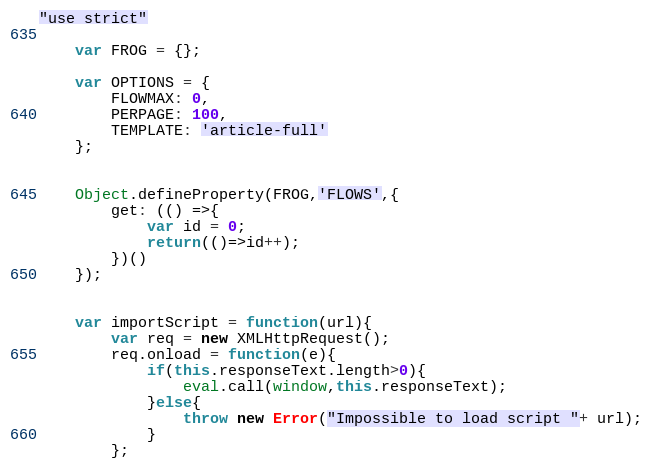<code> <loc_0><loc_0><loc_500><loc_500><_JavaScript_>"use strict"

	var FROG = {};
	
	var OPTIONS = {
		FLOWMAX: 0,
		PERPAGE: 100,
		TEMPLATE: 'article-full'
	};
	
	
	Object.defineProperty(FROG,'FLOWS',{
		get: (() =>{
			var id = 0;
			return(()=>id++);
		})()
	});


	var importScript = function(url){
		var req = new XMLHttpRequest();
		req.onload = function(e){
			if(this.responseText.length>0){
				eval.call(window,this.responseText);
			}else{
				throw new Error("Impossible to load script "+ url);
			}
		};</code> 